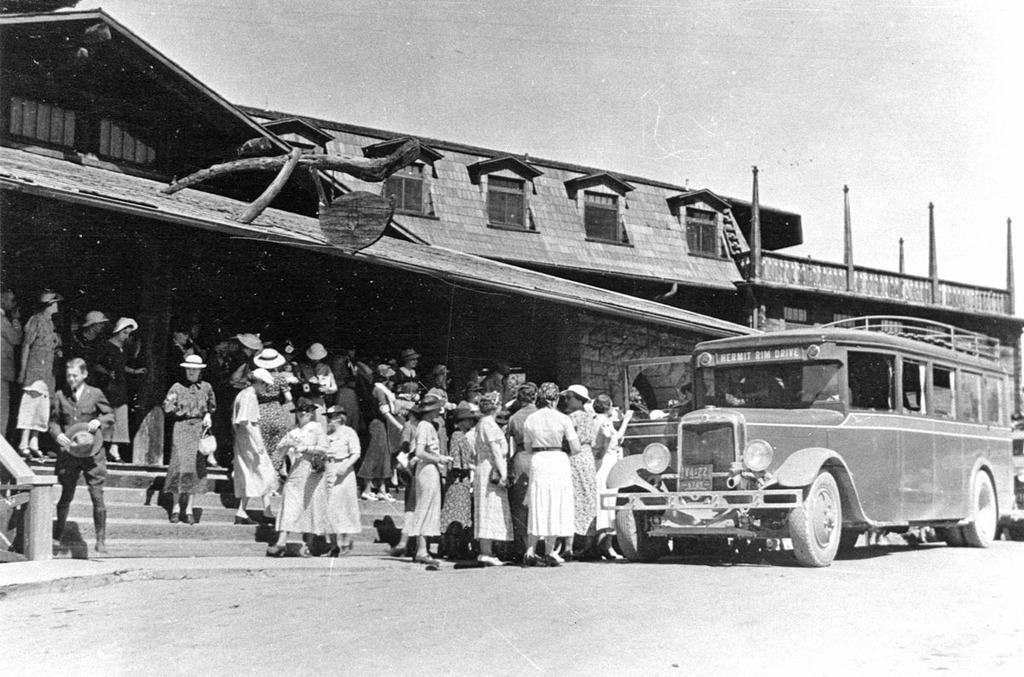What is the color scheme of the image? The image is black and white. What can be seen on the road in the image? There is a vehicle on the road in the image. Where are the people located in the image? The people are on the stairs in the image. What type of structure is present in the image? There is a building in the image. Are there any dinosaurs visible in the image? No, there are no dinosaurs present in the image. Can you see any pipes in the image? There is no mention of pipes in the provided facts, and therefore we cannot determine if any are present in the image. 